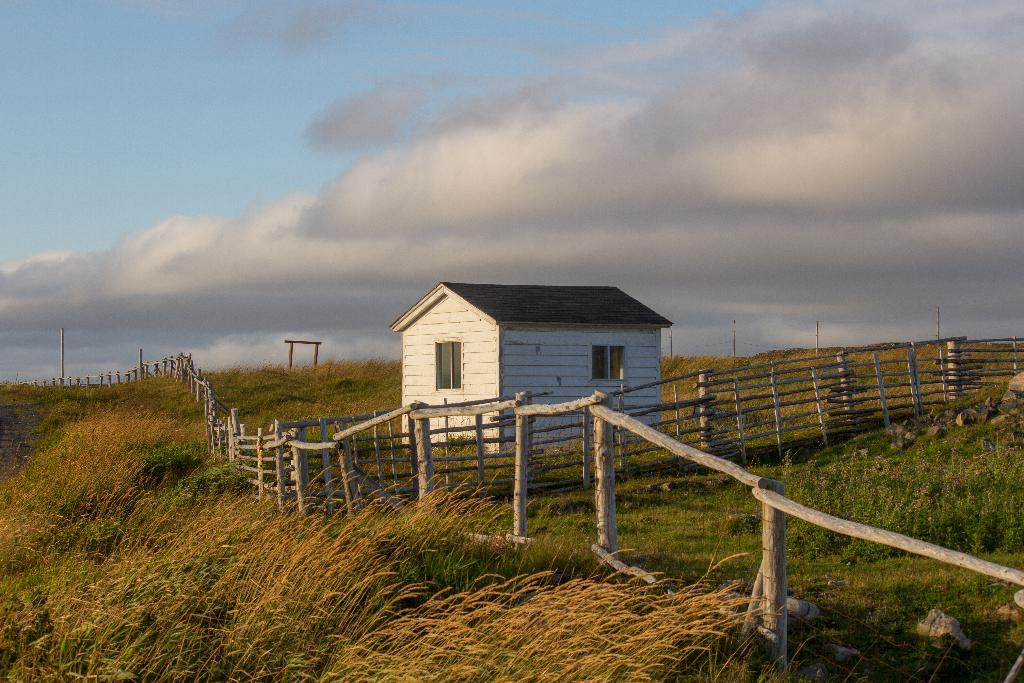What type of structure is present in the image? There is a house in the image. What is covering the ground in the image? The ground is covered with grass and plants. What are the tall, slender objects in the image? There are poles in the image. What can be seen in the sky in the image? The sky is visible with clouds. What is separating the house from the surrounding area in the image? There is a fence in the image. How many pears are hanging from the fence in the image? There are no pears present in the image; the fence is not associated with any fruit. 